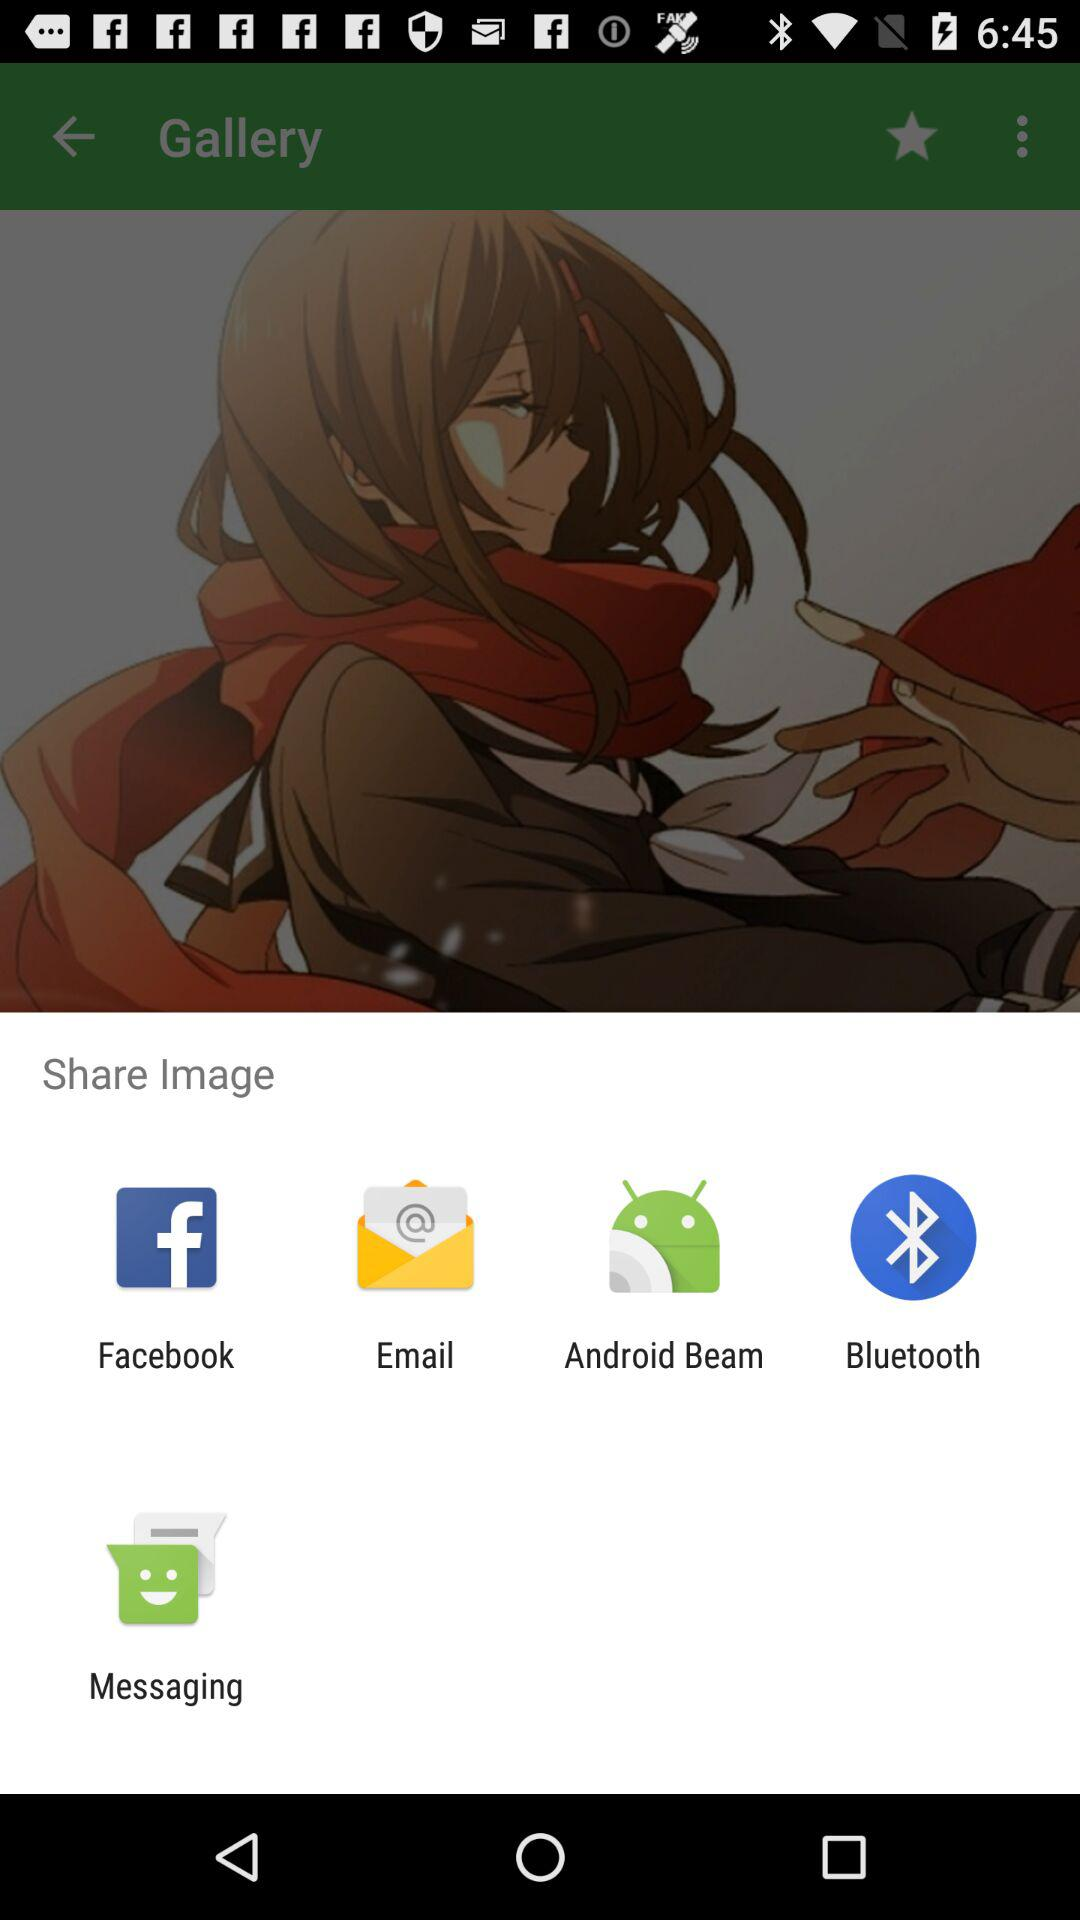What applications are there for sharing the image? The applications for sharing the image are "Facebook", "Email", "Android Beam", "Bluetooth" and "Messaging". 